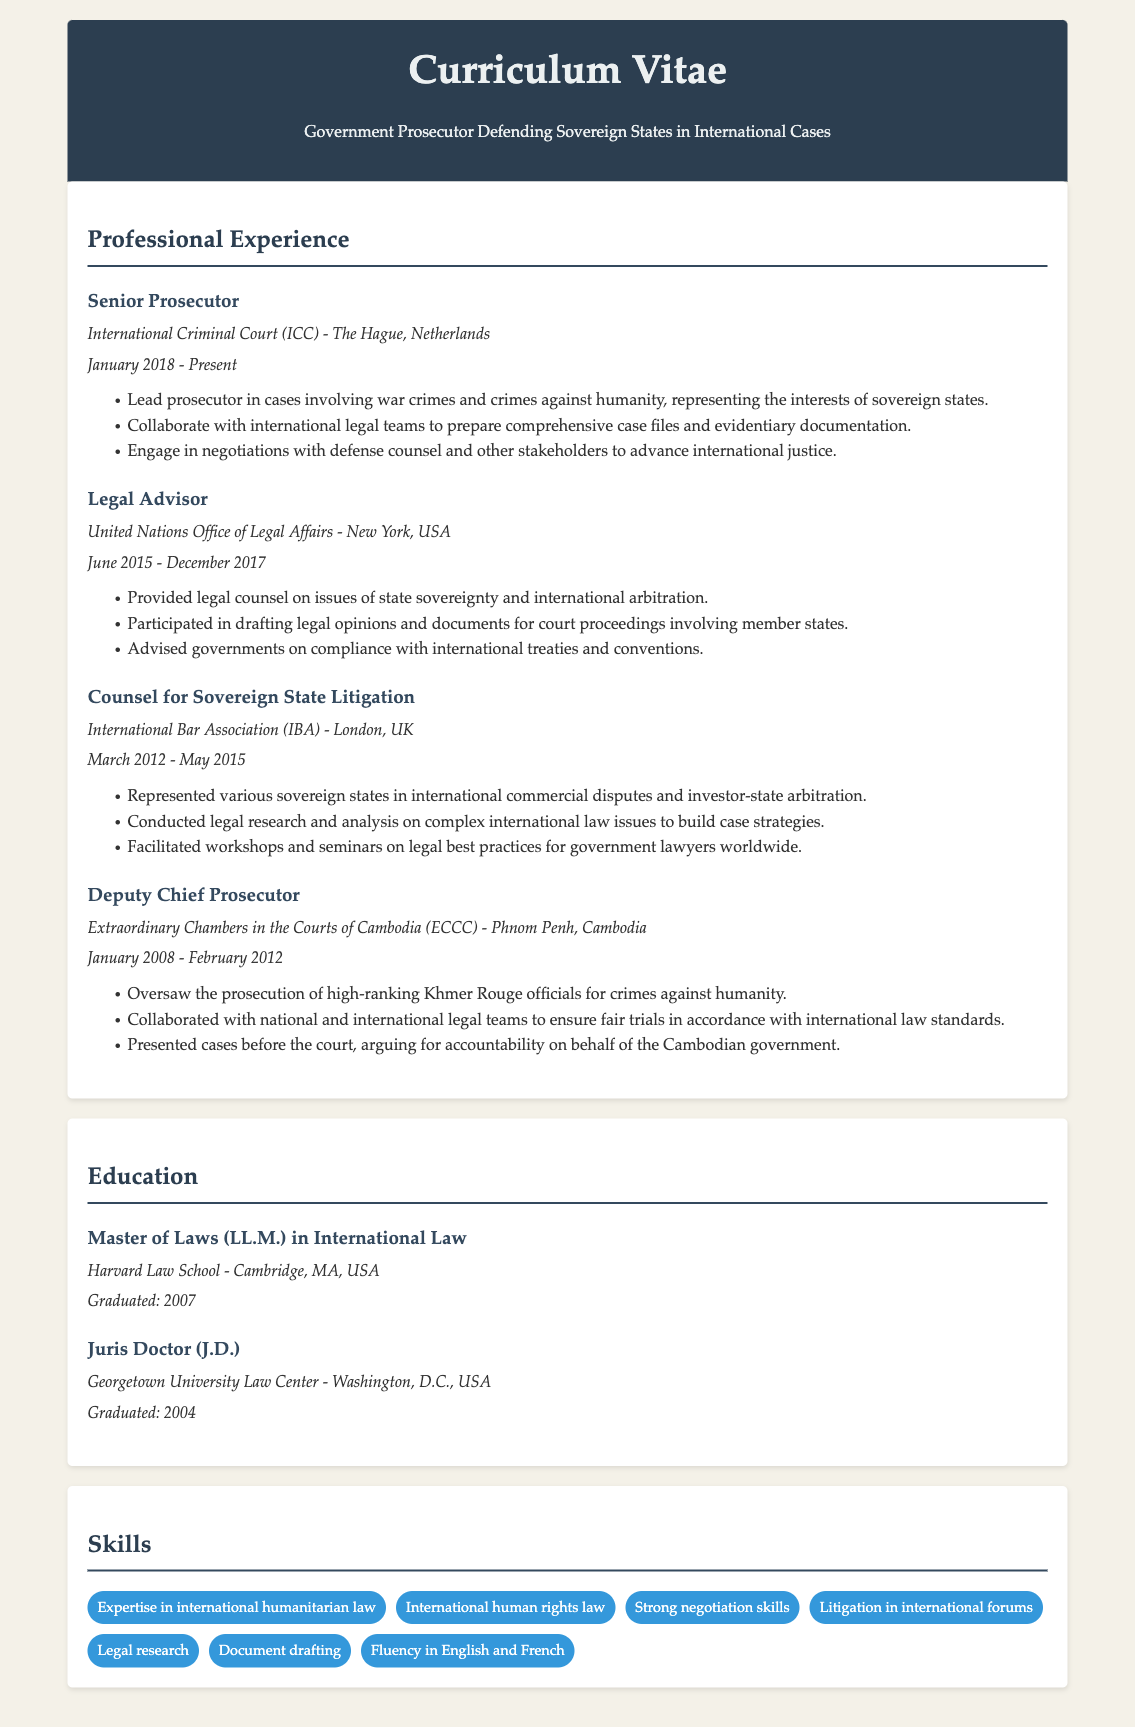What is the current position held? The current position is the Senior Prosecutor at the ICC, as stated in the document.
Answer: Senior Prosecutor Where is the International Criminal Court located? The document specifies the location of the ICC as The Hague, Netherlands.
Answer: The Hague, Netherlands What is the period of service as a Legal Advisor at the United Nations Office of Legal Affairs? The document mentions the start and end dates of this role, which were June 2015 to December 2017.
Answer: June 2015 - December 2017 Which organization did the individual work for as Counsel for Sovereign State Litigation? The document lists the International Bar Association as the organization for this role.
Answer: International Bar Association What significant responsibility did the Deputy Chief Prosecutor oversee? The document indicates that the Deputy Chief Prosecutor oversaw the prosecution of high-ranking Khmer Rouge officials.
Answer: Prosecution of high-ranking Khmer Rouge officials How many years did the individual work at the Extraordinary Chambers in the Courts of Cambodia? The document shows that the individual worked there from January 2008 to February 2012, which amounts to 4 years.
Answer: 4 years What legal degree did the individual obtain from Harvard? The document states that the individual earned a Master of Laws in International Law from Harvard Law School.
Answer: Master of Laws (LL.M.) in International Law What is one of the skills listed in the CV related to negotiation? The document includes "Strong negotiation skills" among the skills listed.
Answer: Strong negotiation skills How many roles are listed under Professional Experience? The document outlines four distinct roles held under Professional Experience.
Answer: Four 